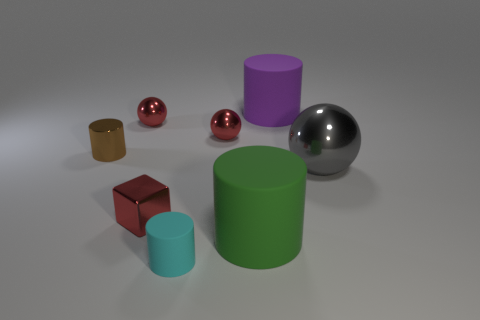What material is the ball that is the same size as the purple matte cylinder?
Your answer should be compact. Metal. There is a small red sphere that is on the right side of the tiny red metallic cube; is there a tiny red thing that is to the left of it?
Your answer should be compact. Yes. How many other objects are the same color as the big shiny thing?
Offer a terse response. 0. The brown metallic thing is what size?
Offer a terse response. Small. Is there a yellow rubber cube?
Provide a succinct answer. No. Are there more tiny shiny cylinders that are in front of the big green cylinder than purple matte objects left of the large purple matte cylinder?
Your answer should be compact. No. There is a small thing that is both behind the tiny metallic cylinder and left of the tiny shiny cube; what material is it?
Keep it short and to the point. Metal. Is the shape of the brown metallic object the same as the big metal object?
Your answer should be compact. No. Are there any other things that are the same size as the green rubber object?
Your answer should be very brief. Yes. What number of brown metallic cylinders are right of the green cylinder?
Your response must be concise. 0. 